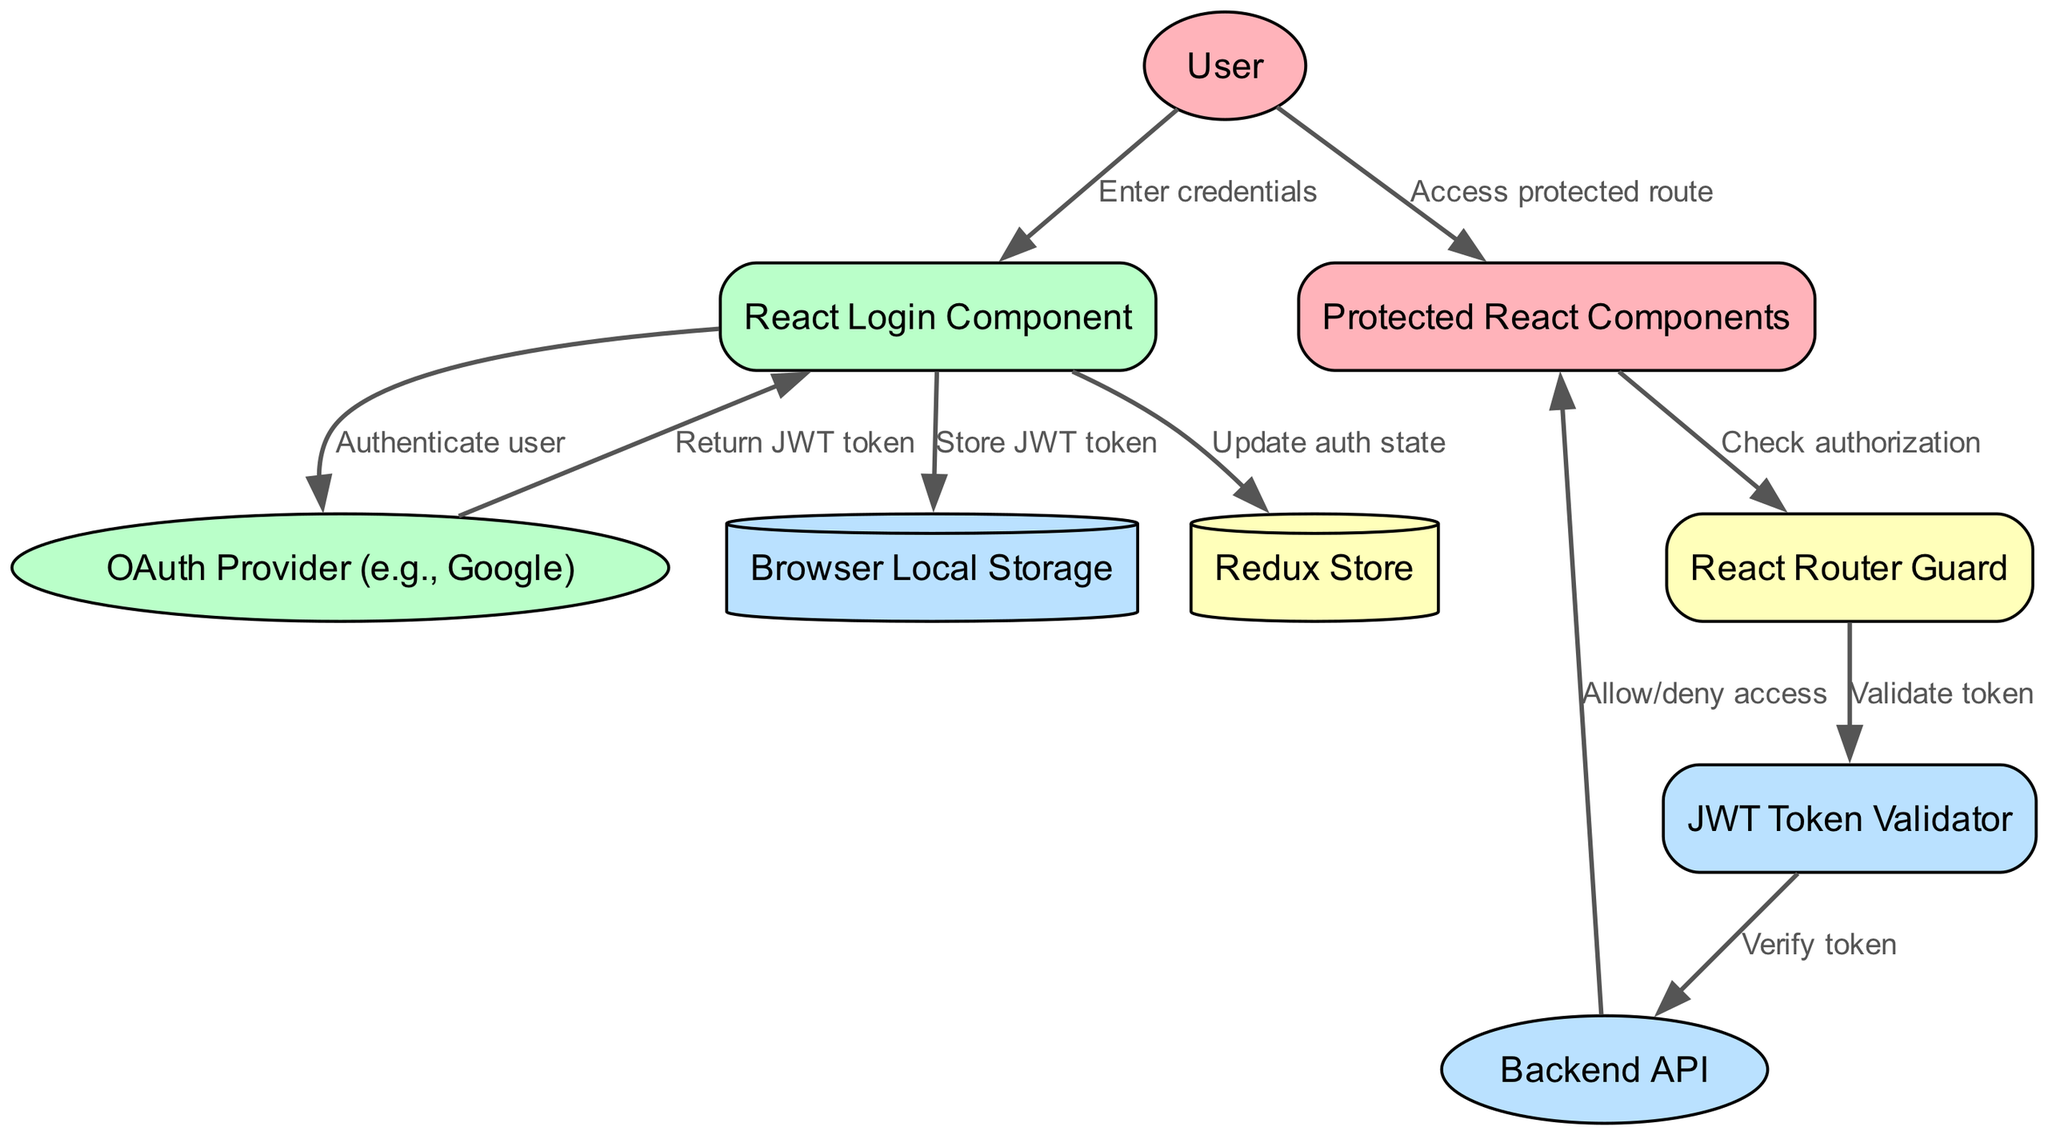What is the first step in the user authentication process? The first step is when the User enters their credentials into the React Login Component. This is the initial interaction that starts the authentication process.
Answer: Enter credentials How many external entities are present in the diagram? The diagram includes three external entities: User, OAuth Provider (e.g., Google), and Backend API. Counting these gives us the total number.
Answer: 3 What does the React Login Component send to the OAuth Provider? The React Login Component sends a request to authenticate the user to the OAuth Provider, which is crucial for the authentication flow.
Answer: Authenticate user What is stored in the Browser Local Storage? The JWT token is stored in the Browser Local Storage by the React Login Component after successful authentication, allowing subsequent requests to use this token.
Answer: Store JWT token What verifies the JWT token in the flow? The JWT Token Validator is responsible for validating the token during the authorization check within the flow before allowing access to protected components.
Answer: Validate token How does the User gain access to protected routes? The User gains access to protected routes by trying to access Protected React Components, which triggers the authorization checking process.
Answer: Access protected route What component checks the authorization before allowing access to Protected React Components? The React Router Guard checks the authorization status before allowing access to the Protected React Components, ensuring that only users with valid tokens enter these sections.
Answer: React Router Guard How many data stores are used in this diagram? There are two data stores referenced in the diagram: Browser Local Storage and Redux Store. Counting these gives us the total.
Answer: 2 What action occurs after the JWT Token Validator verifies the token? After verification, the JWT Token Validator sends a request to the Backend API to verify the token further, bridging the token validation with backend access control.
Answer: Verify token What does the Backend API do in the flow? The Backend API allows or denies access to the Protected React Components based on whether the token validation was successful, acting as the final authority on access rights.
Answer: Allow/deny access 